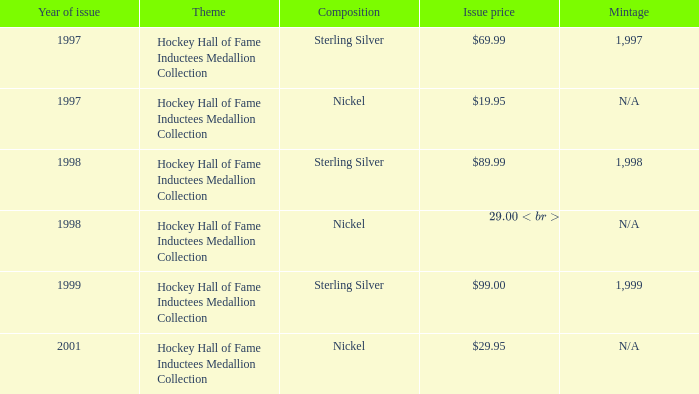Parse the table in full. {'header': ['Year of issue', 'Theme', 'Composition', 'Issue price', 'Mintage'], 'rows': [['1997', 'Hockey Hall of Fame Inductees Medallion Collection', 'Sterling Silver', '$69.99', '1,997'], ['1997', 'Hockey Hall of Fame Inductees Medallion Collection', 'Nickel', '$19.95', 'N/A'], ['1998', 'Hockey Hall of Fame Inductees Medallion Collection', 'Sterling Silver', '$89.99', '1,998'], ['1998', 'Hockey Hall of Fame Inductees Medallion Collection', 'Nickel', '$29.00 (set), $7.50 (individually)', 'N/A'], ['1999', 'Hockey Hall of Fame Inductees Medallion Collection', 'Sterling Silver', '$99.00', '1,999'], ['2001', 'Hockey Hall of Fame Inductees Medallion Collection', 'Nickel', '$29.95', 'N/A']]} Which composition has a problem price of $9 Sterling Silver. 